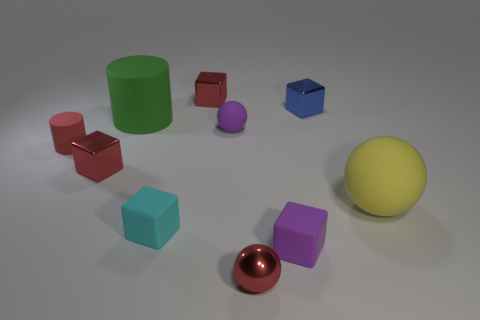Can you tell me the colors of the various objects shown in the image? Certainly! In the image, there are objects in various colors: green, red, blue, cyan, purple, magenta, and yellow, along with a metallic object that appears to have a reflective copper color. 